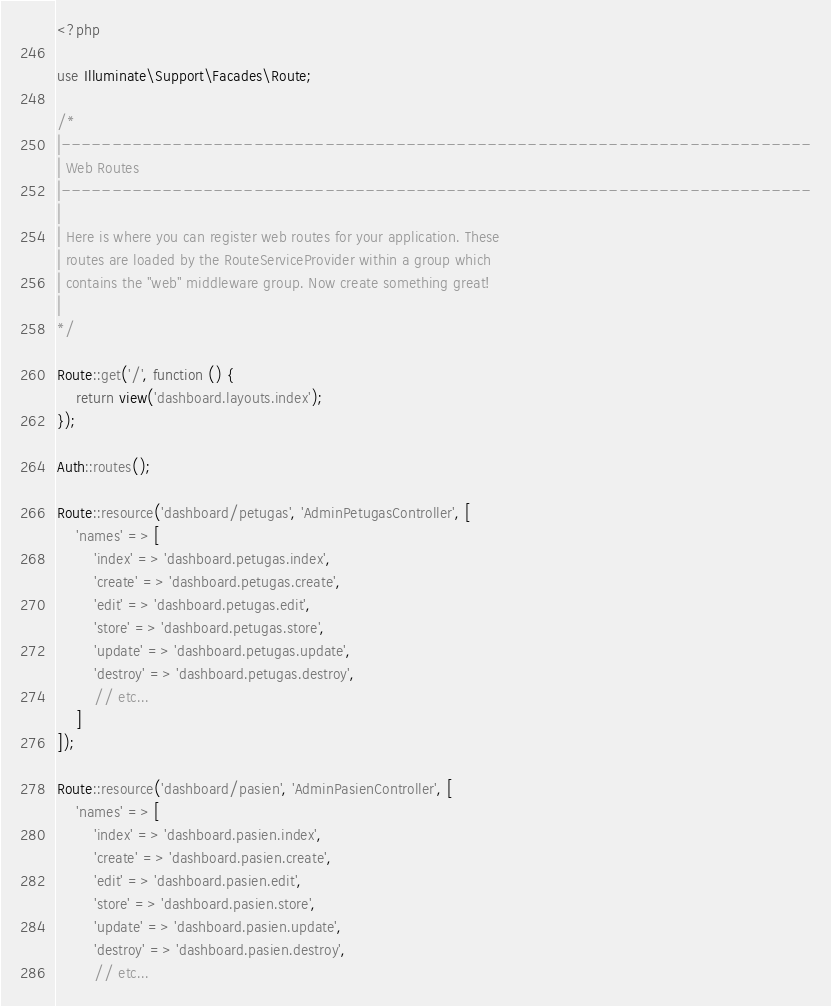<code> <loc_0><loc_0><loc_500><loc_500><_PHP_><?php

use Illuminate\Support\Facades\Route;

/*
|--------------------------------------------------------------------------
| Web Routes
|--------------------------------------------------------------------------
|
| Here is where you can register web routes for your application. These
| routes are loaded by the RouteServiceProvider within a group which
| contains the "web" middleware group. Now create something great!
|
*/

Route::get('/', function () {
    return view('dashboard.layouts.index');
});

Auth::routes();

Route::resource('dashboard/petugas', 'AdminPetugasController', [
    'names' => [
        'index' => 'dashboard.petugas.index',
        'create' => 'dashboard.petugas.create',
        'edit' => 'dashboard.petugas.edit',
        'store' => 'dashboard.petugas.store',
        'update' => 'dashboard.petugas.update',
        'destroy' => 'dashboard.petugas.destroy',
        // etc...
    ]
]);

Route::resource('dashboard/pasien', 'AdminPasienController', [
    'names' => [
        'index' => 'dashboard.pasien.index',
        'create' => 'dashboard.pasien.create',
        'edit' => 'dashboard.pasien.edit',
        'store' => 'dashboard.pasien.store',
        'update' => 'dashboard.pasien.update',
        'destroy' => 'dashboard.pasien.destroy',
        // etc...</code> 